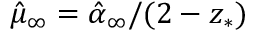<formula> <loc_0><loc_0><loc_500><loc_500>\hat { \mu } _ { \infty } = \hat { \alpha } _ { \infty } / ( 2 - z _ { * } )</formula> 